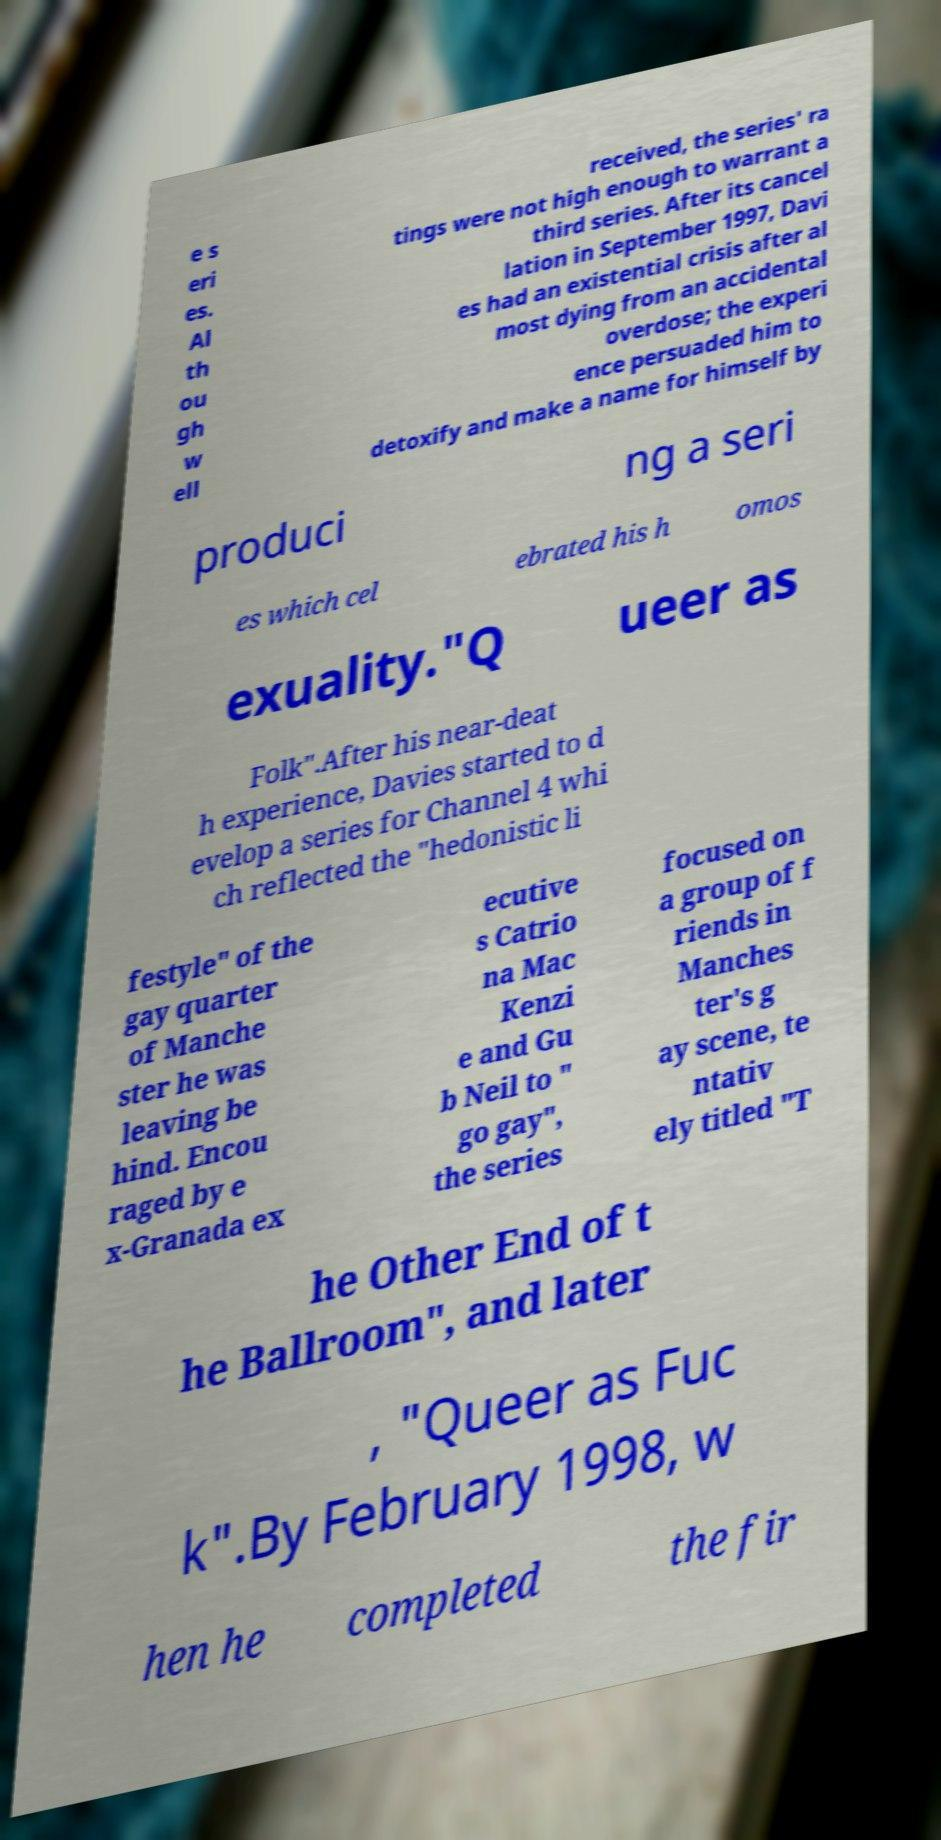Please read and relay the text visible in this image. What does it say? e s eri es. Al th ou gh w ell received, the series' ra tings were not high enough to warrant a third series. After its cancel lation in September 1997, Davi es had an existential crisis after al most dying from an accidental overdose; the experi ence persuaded him to detoxify and make a name for himself by produci ng a seri es which cel ebrated his h omos exuality."Q ueer as Folk".After his near-deat h experience, Davies started to d evelop a series for Channel 4 whi ch reflected the "hedonistic li festyle" of the gay quarter of Manche ster he was leaving be hind. Encou raged by e x-Granada ex ecutive s Catrio na Mac Kenzi e and Gu b Neil to " go gay", the series focused on a group of f riends in Manches ter's g ay scene, te ntativ ely titled "T he Other End of t he Ballroom", and later , "Queer as Fuc k".By February 1998, w hen he completed the fir 